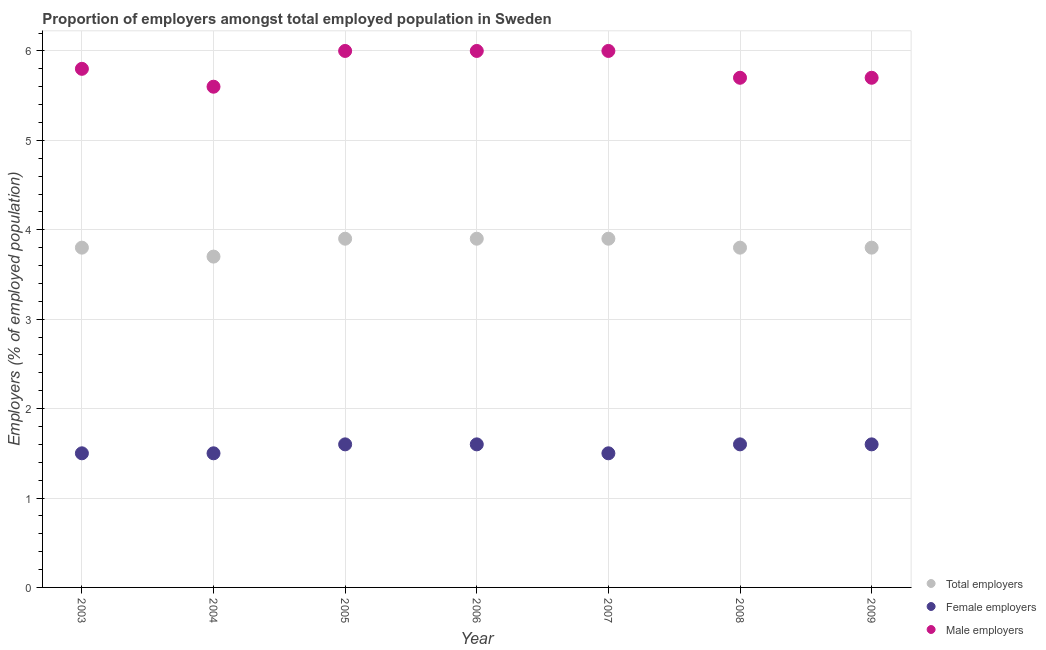What is the percentage of total employers in 2004?
Offer a terse response. 3.7. Across all years, what is the maximum percentage of female employers?
Your answer should be compact. 1.6. Across all years, what is the minimum percentage of total employers?
Ensure brevity in your answer.  3.7. In which year was the percentage of total employers minimum?
Provide a succinct answer. 2004. What is the total percentage of male employers in the graph?
Ensure brevity in your answer.  40.8. What is the difference between the percentage of total employers in 2003 and that in 2006?
Give a very brief answer. -0.1. What is the average percentage of total employers per year?
Provide a succinct answer. 3.83. In the year 2003, what is the difference between the percentage of total employers and percentage of female employers?
Give a very brief answer. 2.3. What is the ratio of the percentage of male employers in 2004 to that in 2009?
Provide a short and direct response. 0.98. Is the difference between the percentage of female employers in 2005 and 2009 greater than the difference between the percentage of total employers in 2005 and 2009?
Offer a very short reply. No. What is the difference between the highest and the lowest percentage of total employers?
Your answer should be very brief. 0.2. Does the percentage of female employers monotonically increase over the years?
Your response must be concise. No. How many dotlines are there?
Your answer should be compact. 3. How many years are there in the graph?
Offer a very short reply. 7. Does the graph contain any zero values?
Provide a short and direct response. No. Does the graph contain grids?
Ensure brevity in your answer.  Yes. Where does the legend appear in the graph?
Offer a very short reply. Bottom right. How many legend labels are there?
Make the answer very short. 3. What is the title of the graph?
Your answer should be compact. Proportion of employers amongst total employed population in Sweden. What is the label or title of the Y-axis?
Your answer should be very brief. Employers (% of employed population). What is the Employers (% of employed population) of Total employers in 2003?
Offer a terse response. 3.8. What is the Employers (% of employed population) of Male employers in 2003?
Provide a short and direct response. 5.8. What is the Employers (% of employed population) in Total employers in 2004?
Give a very brief answer. 3.7. What is the Employers (% of employed population) of Female employers in 2004?
Offer a terse response. 1.5. What is the Employers (% of employed population) of Male employers in 2004?
Your answer should be very brief. 5.6. What is the Employers (% of employed population) of Total employers in 2005?
Keep it short and to the point. 3.9. What is the Employers (% of employed population) in Female employers in 2005?
Provide a succinct answer. 1.6. What is the Employers (% of employed population) in Male employers in 2005?
Give a very brief answer. 6. What is the Employers (% of employed population) of Total employers in 2006?
Ensure brevity in your answer.  3.9. What is the Employers (% of employed population) of Female employers in 2006?
Ensure brevity in your answer.  1.6. What is the Employers (% of employed population) of Male employers in 2006?
Your answer should be very brief. 6. What is the Employers (% of employed population) in Total employers in 2007?
Your response must be concise. 3.9. What is the Employers (% of employed population) of Female employers in 2007?
Provide a short and direct response. 1.5. What is the Employers (% of employed population) in Total employers in 2008?
Provide a short and direct response. 3.8. What is the Employers (% of employed population) of Female employers in 2008?
Offer a terse response. 1.6. What is the Employers (% of employed population) of Male employers in 2008?
Your response must be concise. 5.7. What is the Employers (% of employed population) of Total employers in 2009?
Provide a succinct answer. 3.8. What is the Employers (% of employed population) in Female employers in 2009?
Offer a very short reply. 1.6. What is the Employers (% of employed population) of Male employers in 2009?
Ensure brevity in your answer.  5.7. Across all years, what is the maximum Employers (% of employed population) in Total employers?
Give a very brief answer. 3.9. Across all years, what is the maximum Employers (% of employed population) in Female employers?
Ensure brevity in your answer.  1.6. Across all years, what is the maximum Employers (% of employed population) in Male employers?
Your answer should be compact. 6. Across all years, what is the minimum Employers (% of employed population) of Total employers?
Your response must be concise. 3.7. Across all years, what is the minimum Employers (% of employed population) in Male employers?
Your answer should be compact. 5.6. What is the total Employers (% of employed population) in Total employers in the graph?
Your response must be concise. 26.8. What is the total Employers (% of employed population) of Male employers in the graph?
Give a very brief answer. 40.8. What is the difference between the Employers (% of employed population) of Male employers in 2003 and that in 2004?
Offer a very short reply. 0.2. What is the difference between the Employers (% of employed population) of Male employers in 2003 and that in 2005?
Your answer should be compact. -0.2. What is the difference between the Employers (% of employed population) in Total employers in 2003 and that in 2007?
Offer a terse response. -0.1. What is the difference between the Employers (% of employed population) in Female employers in 2003 and that in 2007?
Ensure brevity in your answer.  0. What is the difference between the Employers (% of employed population) in Male employers in 2003 and that in 2007?
Make the answer very short. -0.2. What is the difference between the Employers (% of employed population) in Female employers in 2003 and that in 2008?
Keep it short and to the point. -0.1. What is the difference between the Employers (% of employed population) of Male employers in 2003 and that in 2009?
Give a very brief answer. 0.1. What is the difference between the Employers (% of employed population) of Total employers in 2004 and that in 2005?
Offer a very short reply. -0.2. What is the difference between the Employers (% of employed population) in Female employers in 2004 and that in 2005?
Provide a succinct answer. -0.1. What is the difference between the Employers (% of employed population) in Total employers in 2004 and that in 2006?
Your response must be concise. -0.2. What is the difference between the Employers (% of employed population) in Total employers in 2004 and that in 2007?
Your answer should be very brief. -0.2. What is the difference between the Employers (% of employed population) of Female employers in 2004 and that in 2007?
Ensure brevity in your answer.  0. What is the difference between the Employers (% of employed population) in Female employers in 2004 and that in 2008?
Ensure brevity in your answer.  -0.1. What is the difference between the Employers (% of employed population) of Male employers in 2004 and that in 2008?
Ensure brevity in your answer.  -0.1. What is the difference between the Employers (% of employed population) in Total employers in 2004 and that in 2009?
Keep it short and to the point. -0.1. What is the difference between the Employers (% of employed population) in Female employers in 2004 and that in 2009?
Ensure brevity in your answer.  -0.1. What is the difference between the Employers (% of employed population) in Male employers in 2004 and that in 2009?
Give a very brief answer. -0.1. What is the difference between the Employers (% of employed population) of Total employers in 2005 and that in 2006?
Your response must be concise. 0. What is the difference between the Employers (% of employed population) in Female employers in 2005 and that in 2007?
Your answer should be compact. 0.1. What is the difference between the Employers (% of employed population) in Male employers in 2005 and that in 2007?
Provide a succinct answer. 0. What is the difference between the Employers (% of employed population) of Female employers in 2005 and that in 2008?
Your answer should be compact. 0. What is the difference between the Employers (% of employed population) in Male employers in 2005 and that in 2008?
Give a very brief answer. 0.3. What is the difference between the Employers (% of employed population) of Total employers in 2005 and that in 2009?
Provide a succinct answer. 0.1. What is the difference between the Employers (% of employed population) in Female employers in 2005 and that in 2009?
Keep it short and to the point. 0. What is the difference between the Employers (% of employed population) in Female employers in 2006 and that in 2007?
Offer a very short reply. 0.1. What is the difference between the Employers (% of employed population) in Female employers in 2006 and that in 2008?
Provide a succinct answer. 0. What is the difference between the Employers (% of employed population) in Female employers in 2006 and that in 2009?
Give a very brief answer. 0. What is the difference between the Employers (% of employed population) in Male employers in 2006 and that in 2009?
Offer a terse response. 0.3. What is the difference between the Employers (% of employed population) in Female employers in 2007 and that in 2008?
Keep it short and to the point. -0.1. What is the difference between the Employers (% of employed population) in Total employers in 2007 and that in 2009?
Ensure brevity in your answer.  0.1. What is the difference between the Employers (% of employed population) of Male employers in 2007 and that in 2009?
Offer a terse response. 0.3. What is the difference between the Employers (% of employed population) in Total employers in 2008 and that in 2009?
Provide a short and direct response. 0. What is the difference between the Employers (% of employed population) in Female employers in 2008 and that in 2009?
Make the answer very short. 0. What is the difference between the Employers (% of employed population) of Male employers in 2008 and that in 2009?
Provide a succinct answer. 0. What is the difference between the Employers (% of employed population) of Total employers in 2003 and the Employers (% of employed population) of Female employers in 2004?
Offer a terse response. 2.3. What is the difference between the Employers (% of employed population) of Total employers in 2003 and the Employers (% of employed population) of Male employers in 2004?
Keep it short and to the point. -1.8. What is the difference between the Employers (% of employed population) of Female employers in 2003 and the Employers (% of employed population) of Male employers in 2004?
Offer a terse response. -4.1. What is the difference between the Employers (% of employed population) of Total employers in 2003 and the Employers (% of employed population) of Female employers in 2005?
Your response must be concise. 2.2. What is the difference between the Employers (% of employed population) of Total employers in 2003 and the Employers (% of employed population) of Male employers in 2005?
Give a very brief answer. -2.2. What is the difference between the Employers (% of employed population) in Total employers in 2003 and the Employers (% of employed population) in Female employers in 2007?
Provide a short and direct response. 2.3. What is the difference between the Employers (% of employed population) of Total employers in 2003 and the Employers (% of employed population) of Male employers in 2007?
Keep it short and to the point. -2.2. What is the difference between the Employers (% of employed population) of Female employers in 2003 and the Employers (% of employed population) of Male employers in 2007?
Offer a terse response. -4.5. What is the difference between the Employers (% of employed population) in Total employers in 2003 and the Employers (% of employed population) in Female employers in 2008?
Give a very brief answer. 2.2. What is the difference between the Employers (% of employed population) of Total employers in 2003 and the Employers (% of employed population) of Male employers in 2008?
Give a very brief answer. -1.9. What is the difference between the Employers (% of employed population) in Female employers in 2003 and the Employers (% of employed population) in Male employers in 2008?
Keep it short and to the point. -4.2. What is the difference between the Employers (% of employed population) in Total employers in 2003 and the Employers (% of employed population) in Female employers in 2009?
Keep it short and to the point. 2.2. What is the difference between the Employers (% of employed population) in Total employers in 2003 and the Employers (% of employed population) in Male employers in 2009?
Give a very brief answer. -1.9. What is the difference between the Employers (% of employed population) in Female employers in 2003 and the Employers (% of employed population) in Male employers in 2009?
Your answer should be very brief. -4.2. What is the difference between the Employers (% of employed population) of Total employers in 2004 and the Employers (% of employed population) of Female employers in 2006?
Provide a short and direct response. 2.1. What is the difference between the Employers (% of employed population) in Total employers in 2004 and the Employers (% of employed population) in Female employers in 2007?
Give a very brief answer. 2.2. What is the difference between the Employers (% of employed population) in Total employers in 2004 and the Employers (% of employed population) in Male employers in 2007?
Your answer should be compact. -2.3. What is the difference between the Employers (% of employed population) in Female employers in 2004 and the Employers (% of employed population) in Male employers in 2007?
Give a very brief answer. -4.5. What is the difference between the Employers (% of employed population) of Total employers in 2004 and the Employers (% of employed population) of Female employers in 2008?
Offer a terse response. 2.1. What is the difference between the Employers (% of employed population) of Total employers in 2004 and the Employers (% of employed population) of Male employers in 2009?
Make the answer very short. -2. What is the difference between the Employers (% of employed population) in Female employers in 2004 and the Employers (% of employed population) in Male employers in 2009?
Provide a succinct answer. -4.2. What is the difference between the Employers (% of employed population) of Total employers in 2005 and the Employers (% of employed population) of Female employers in 2006?
Make the answer very short. 2.3. What is the difference between the Employers (% of employed population) of Total employers in 2005 and the Employers (% of employed population) of Female employers in 2007?
Provide a short and direct response. 2.4. What is the difference between the Employers (% of employed population) in Total employers in 2005 and the Employers (% of employed population) in Male employers in 2007?
Ensure brevity in your answer.  -2.1. What is the difference between the Employers (% of employed population) of Female employers in 2005 and the Employers (% of employed population) of Male employers in 2007?
Your response must be concise. -4.4. What is the difference between the Employers (% of employed population) of Total employers in 2005 and the Employers (% of employed population) of Male employers in 2008?
Your answer should be compact. -1.8. What is the difference between the Employers (% of employed population) of Female employers in 2006 and the Employers (% of employed population) of Male employers in 2007?
Provide a succinct answer. -4.4. What is the difference between the Employers (% of employed population) of Total employers in 2006 and the Employers (% of employed population) of Female employers in 2008?
Your response must be concise. 2.3. What is the difference between the Employers (% of employed population) of Total employers in 2006 and the Employers (% of employed population) of Male employers in 2008?
Your response must be concise. -1.8. What is the difference between the Employers (% of employed population) in Total employers in 2006 and the Employers (% of employed population) in Female employers in 2009?
Your response must be concise. 2.3. What is the difference between the Employers (% of employed population) in Total employers in 2006 and the Employers (% of employed population) in Male employers in 2009?
Provide a succinct answer. -1.8. What is the difference between the Employers (% of employed population) in Total employers in 2007 and the Employers (% of employed population) in Male employers in 2009?
Offer a terse response. -1.8. What is the difference between the Employers (% of employed population) of Female employers in 2007 and the Employers (% of employed population) of Male employers in 2009?
Provide a succinct answer. -4.2. What is the difference between the Employers (% of employed population) of Total employers in 2008 and the Employers (% of employed population) of Female employers in 2009?
Give a very brief answer. 2.2. What is the difference between the Employers (% of employed population) of Total employers in 2008 and the Employers (% of employed population) of Male employers in 2009?
Give a very brief answer. -1.9. What is the difference between the Employers (% of employed population) in Female employers in 2008 and the Employers (% of employed population) in Male employers in 2009?
Your answer should be compact. -4.1. What is the average Employers (% of employed population) of Total employers per year?
Give a very brief answer. 3.83. What is the average Employers (% of employed population) in Female employers per year?
Your response must be concise. 1.56. What is the average Employers (% of employed population) in Male employers per year?
Offer a terse response. 5.83. In the year 2003, what is the difference between the Employers (% of employed population) of Total employers and Employers (% of employed population) of Female employers?
Your response must be concise. 2.3. In the year 2003, what is the difference between the Employers (% of employed population) in Total employers and Employers (% of employed population) in Male employers?
Give a very brief answer. -2. In the year 2003, what is the difference between the Employers (% of employed population) of Female employers and Employers (% of employed population) of Male employers?
Your response must be concise. -4.3. In the year 2004, what is the difference between the Employers (% of employed population) in Total employers and Employers (% of employed population) in Female employers?
Keep it short and to the point. 2.2. In the year 2004, what is the difference between the Employers (% of employed population) in Total employers and Employers (% of employed population) in Male employers?
Offer a terse response. -1.9. In the year 2004, what is the difference between the Employers (% of employed population) in Female employers and Employers (% of employed population) in Male employers?
Offer a very short reply. -4.1. In the year 2005, what is the difference between the Employers (% of employed population) of Total employers and Employers (% of employed population) of Male employers?
Offer a very short reply. -2.1. In the year 2005, what is the difference between the Employers (% of employed population) of Female employers and Employers (% of employed population) of Male employers?
Offer a very short reply. -4.4. In the year 2006, what is the difference between the Employers (% of employed population) in Total employers and Employers (% of employed population) in Male employers?
Your answer should be very brief. -2.1. In the year 2006, what is the difference between the Employers (% of employed population) in Female employers and Employers (% of employed population) in Male employers?
Offer a very short reply. -4.4. In the year 2007, what is the difference between the Employers (% of employed population) of Total employers and Employers (% of employed population) of Male employers?
Offer a very short reply. -2.1. In the year 2007, what is the difference between the Employers (% of employed population) in Female employers and Employers (% of employed population) in Male employers?
Make the answer very short. -4.5. In the year 2008, what is the difference between the Employers (% of employed population) of Total employers and Employers (% of employed population) of Male employers?
Offer a very short reply. -1.9. In the year 2008, what is the difference between the Employers (% of employed population) in Female employers and Employers (% of employed population) in Male employers?
Your answer should be compact. -4.1. In the year 2009, what is the difference between the Employers (% of employed population) of Total employers and Employers (% of employed population) of Female employers?
Provide a succinct answer. 2.2. What is the ratio of the Employers (% of employed population) of Male employers in 2003 to that in 2004?
Ensure brevity in your answer.  1.04. What is the ratio of the Employers (% of employed population) in Total employers in 2003 to that in 2005?
Your response must be concise. 0.97. What is the ratio of the Employers (% of employed population) of Female employers in 2003 to that in 2005?
Your response must be concise. 0.94. What is the ratio of the Employers (% of employed population) of Male employers in 2003 to that in 2005?
Keep it short and to the point. 0.97. What is the ratio of the Employers (% of employed population) of Total employers in 2003 to that in 2006?
Offer a terse response. 0.97. What is the ratio of the Employers (% of employed population) in Female employers in 2003 to that in 2006?
Give a very brief answer. 0.94. What is the ratio of the Employers (% of employed population) of Male employers in 2003 to that in 2006?
Your response must be concise. 0.97. What is the ratio of the Employers (% of employed population) in Total employers in 2003 to that in 2007?
Keep it short and to the point. 0.97. What is the ratio of the Employers (% of employed population) in Female employers in 2003 to that in 2007?
Keep it short and to the point. 1. What is the ratio of the Employers (% of employed population) in Male employers in 2003 to that in 2007?
Your answer should be compact. 0.97. What is the ratio of the Employers (% of employed population) in Male employers in 2003 to that in 2008?
Your response must be concise. 1.02. What is the ratio of the Employers (% of employed population) in Male employers in 2003 to that in 2009?
Give a very brief answer. 1.02. What is the ratio of the Employers (% of employed population) in Total employers in 2004 to that in 2005?
Your answer should be compact. 0.95. What is the ratio of the Employers (% of employed population) in Female employers in 2004 to that in 2005?
Offer a terse response. 0.94. What is the ratio of the Employers (% of employed population) in Male employers in 2004 to that in 2005?
Offer a very short reply. 0.93. What is the ratio of the Employers (% of employed population) in Total employers in 2004 to that in 2006?
Offer a very short reply. 0.95. What is the ratio of the Employers (% of employed population) of Male employers in 2004 to that in 2006?
Offer a very short reply. 0.93. What is the ratio of the Employers (% of employed population) in Total employers in 2004 to that in 2007?
Make the answer very short. 0.95. What is the ratio of the Employers (% of employed population) in Female employers in 2004 to that in 2007?
Offer a very short reply. 1. What is the ratio of the Employers (% of employed population) of Male employers in 2004 to that in 2007?
Make the answer very short. 0.93. What is the ratio of the Employers (% of employed population) of Total employers in 2004 to that in 2008?
Make the answer very short. 0.97. What is the ratio of the Employers (% of employed population) of Female employers in 2004 to that in 2008?
Your response must be concise. 0.94. What is the ratio of the Employers (% of employed population) in Male employers in 2004 to that in 2008?
Your answer should be very brief. 0.98. What is the ratio of the Employers (% of employed population) of Total employers in 2004 to that in 2009?
Offer a very short reply. 0.97. What is the ratio of the Employers (% of employed population) in Female employers in 2004 to that in 2009?
Offer a very short reply. 0.94. What is the ratio of the Employers (% of employed population) in Male employers in 2004 to that in 2009?
Offer a very short reply. 0.98. What is the ratio of the Employers (% of employed population) in Total employers in 2005 to that in 2006?
Your response must be concise. 1. What is the ratio of the Employers (% of employed population) of Male employers in 2005 to that in 2006?
Offer a very short reply. 1. What is the ratio of the Employers (% of employed population) in Total employers in 2005 to that in 2007?
Give a very brief answer. 1. What is the ratio of the Employers (% of employed population) in Female employers in 2005 to that in 2007?
Make the answer very short. 1.07. What is the ratio of the Employers (% of employed population) of Male employers in 2005 to that in 2007?
Make the answer very short. 1. What is the ratio of the Employers (% of employed population) of Total employers in 2005 to that in 2008?
Your answer should be very brief. 1.03. What is the ratio of the Employers (% of employed population) of Female employers in 2005 to that in 2008?
Give a very brief answer. 1. What is the ratio of the Employers (% of employed population) of Male employers in 2005 to that in 2008?
Keep it short and to the point. 1.05. What is the ratio of the Employers (% of employed population) of Total employers in 2005 to that in 2009?
Make the answer very short. 1.03. What is the ratio of the Employers (% of employed population) of Female employers in 2005 to that in 2009?
Provide a succinct answer. 1. What is the ratio of the Employers (% of employed population) of Male employers in 2005 to that in 2009?
Your answer should be compact. 1.05. What is the ratio of the Employers (% of employed population) in Female employers in 2006 to that in 2007?
Offer a very short reply. 1.07. What is the ratio of the Employers (% of employed population) of Total employers in 2006 to that in 2008?
Offer a terse response. 1.03. What is the ratio of the Employers (% of employed population) in Female employers in 2006 to that in 2008?
Your answer should be compact. 1. What is the ratio of the Employers (% of employed population) of Male employers in 2006 to that in 2008?
Your response must be concise. 1.05. What is the ratio of the Employers (% of employed population) in Total employers in 2006 to that in 2009?
Your answer should be compact. 1.03. What is the ratio of the Employers (% of employed population) in Female employers in 2006 to that in 2009?
Keep it short and to the point. 1. What is the ratio of the Employers (% of employed population) in Male employers in 2006 to that in 2009?
Offer a very short reply. 1.05. What is the ratio of the Employers (% of employed population) of Total employers in 2007 to that in 2008?
Offer a very short reply. 1.03. What is the ratio of the Employers (% of employed population) in Female employers in 2007 to that in 2008?
Ensure brevity in your answer.  0.94. What is the ratio of the Employers (% of employed population) of Male employers in 2007 to that in 2008?
Offer a terse response. 1.05. What is the ratio of the Employers (% of employed population) of Total employers in 2007 to that in 2009?
Keep it short and to the point. 1.03. What is the ratio of the Employers (% of employed population) of Male employers in 2007 to that in 2009?
Keep it short and to the point. 1.05. What is the ratio of the Employers (% of employed population) in Total employers in 2008 to that in 2009?
Offer a terse response. 1. What is the difference between the highest and the second highest Employers (% of employed population) in Total employers?
Your answer should be compact. 0. What is the difference between the highest and the second highest Employers (% of employed population) in Male employers?
Make the answer very short. 0. What is the difference between the highest and the lowest Employers (% of employed population) of Total employers?
Offer a very short reply. 0.2. What is the difference between the highest and the lowest Employers (% of employed population) of Male employers?
Provide a succinct answer. 0.4. 